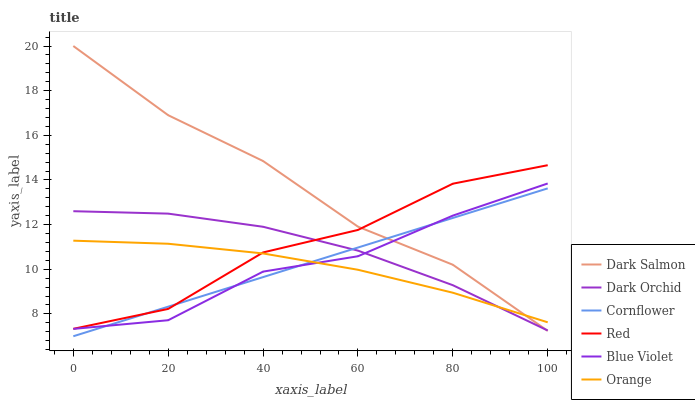Does Orange have the minimum area under the curve?
Answer yes or no. Yes. Does Dark Salmon have the maximum area under the curve?
Answer yes or no. Yes. Does Dark Orchid have the minimum area under the curve?
Answer yes or no. No. Does Dark Orchid have the maximum area under the curve?
Answer yes or no. No. Is Cornflower the smoothest?
Answer yes or no. Yes. Is Red the roughest?
Answer yes or no. Yes. Is Dark Salmon the smoothest?
Answer yes or no. No. Is Dark Salmon the roughest?
Answer yes or no. No. Does Cornflower have the lowest value?
Answer yes or no. Yes. Does Dark Salmon have the lowest value?
Answer yes or no. No. Does Dark Salmon have the highest value?
Answer yes or no. Yes. Does Dark Orchid have the highest value?
Answer yes or no. No. Is Blue Violet less than Red?
Answer yes or no. Yes. Is Red greater than Blue Violet?
Answer yes or no. Yes. Does Cornflower intersect Dark Orchid?
Answer yes or no. Yes. Is Cornflower less than Dark Orchid?
Answer yes or no. No. Is Cornflower greater than Dark Orchid?
Answer yes or no. No. Does Blue Violet intersect Red?
Answer yes or no. No. 